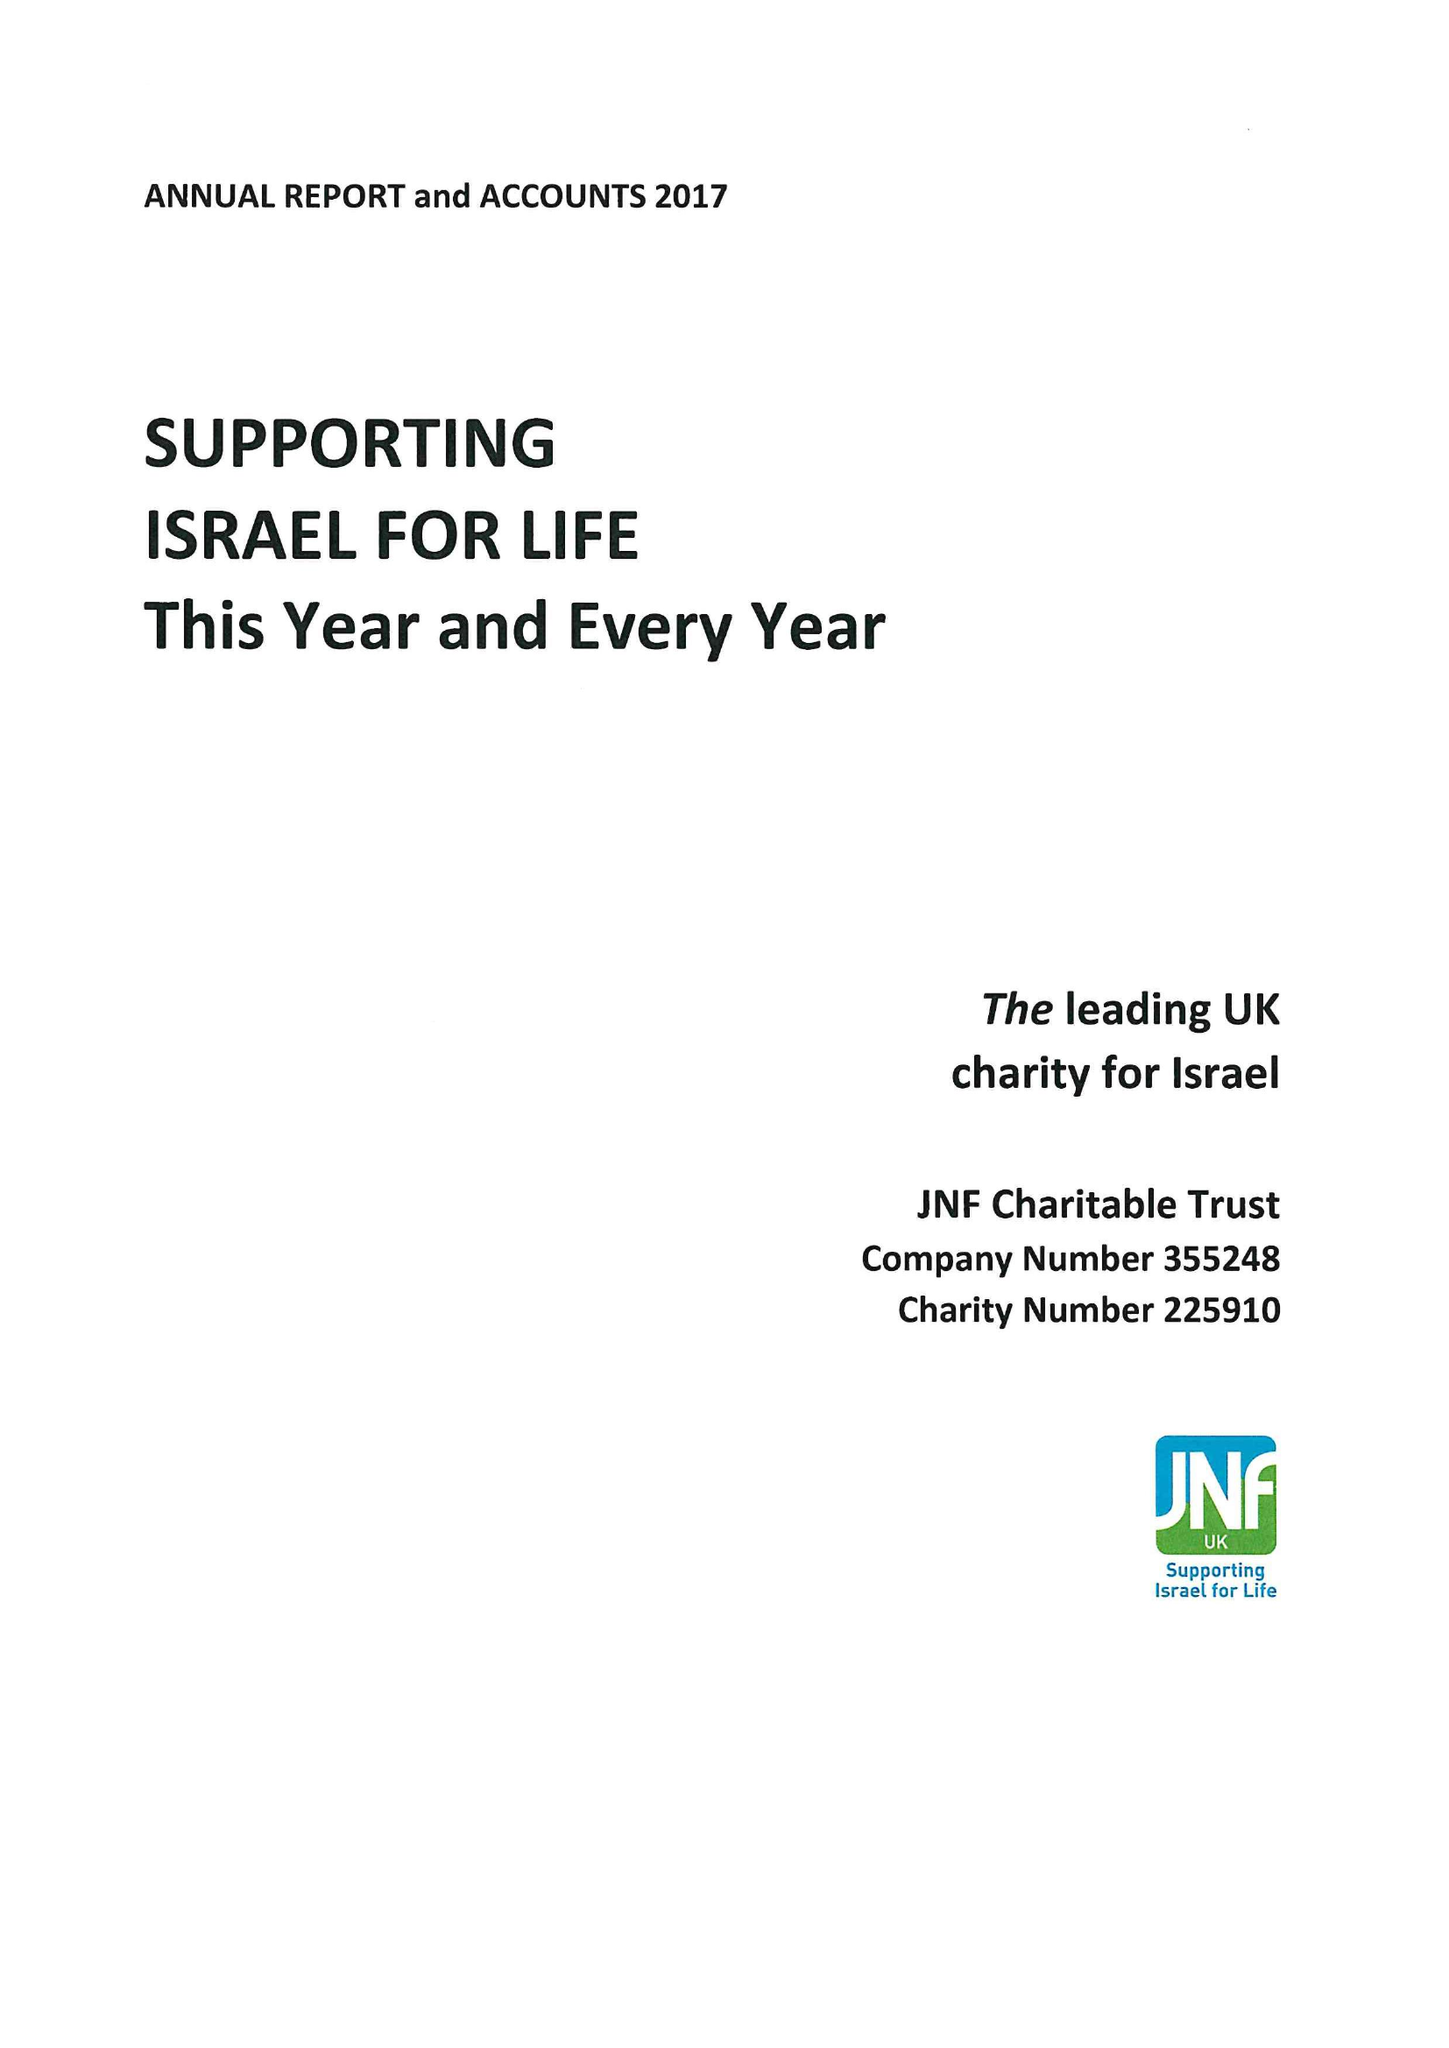What is the value for the address__post_town?
Answer the question using a single word or phrase. LONDON 